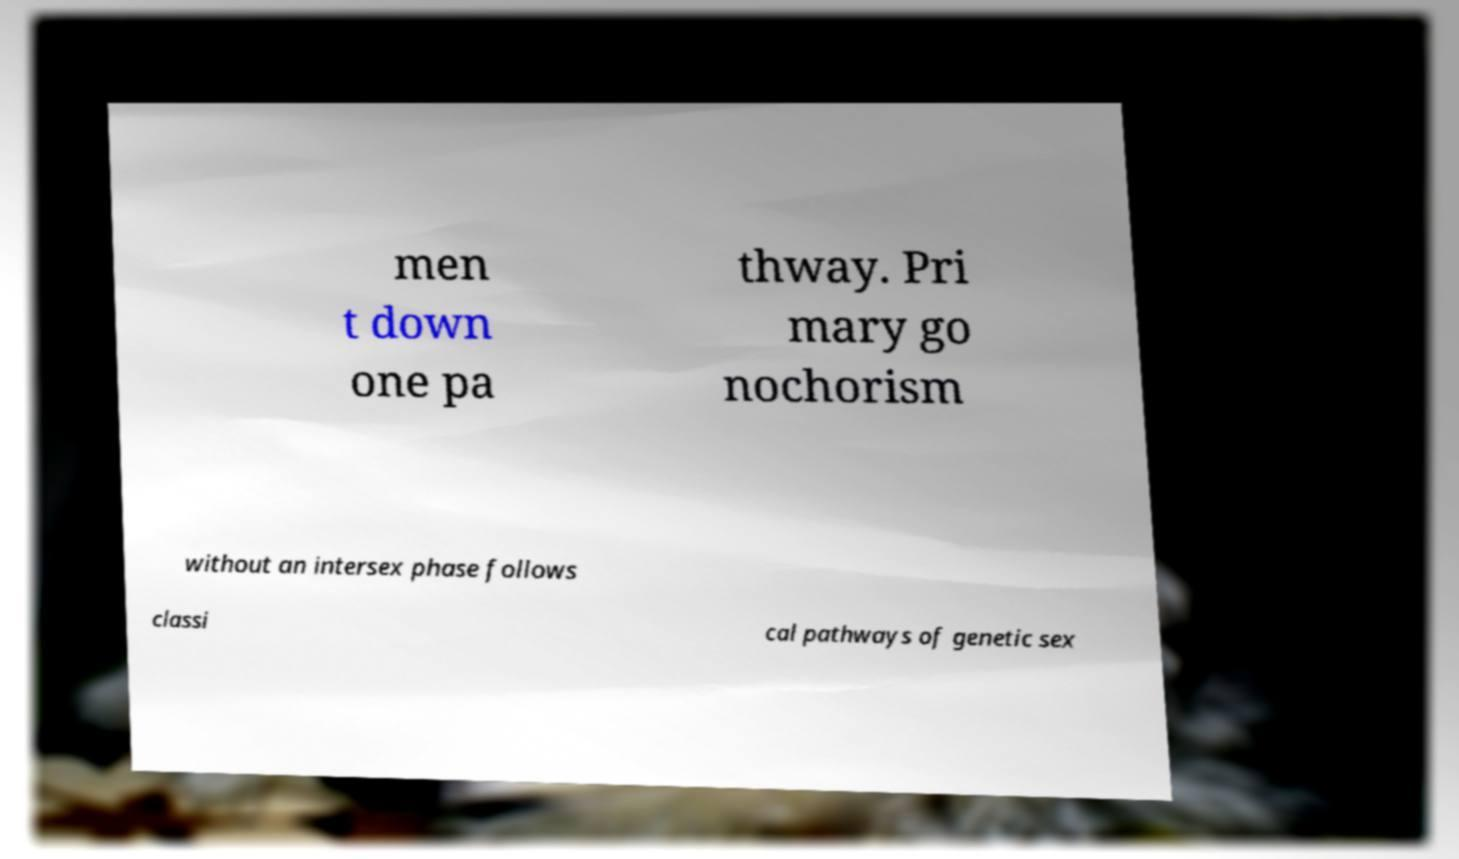What messages or text are displayed in this image? I need them in a readable, typed format. men t down one pa thway. Pri mary go nochorism without an intersex phase follows classi cal pathways of genetic sex 